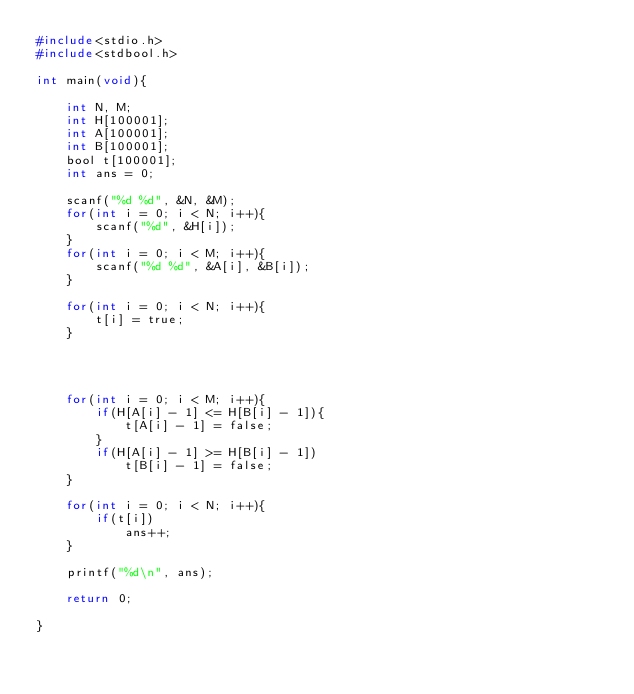Convert code to text. <code><loc_0><loc_0><loc_500><loc_500><_C_>#include<stdio.h>
#include<stdbool.h>

int main(void){

	int N, M;
	int H[100001];
	int A[100001];
	int B[100001];
	bool t[100001];
	int ans = 0;

	scanf("%d %d", &N, &M);
	for(int i = 0; i < N; i++){
		scanf("%d", &H[i]);
	}
	for(int i = 0; i < M; i++){
		scanf("%d %d", &A[i], &B[i]);
	}

	for(int i = 0; i < N; i++){
		t[i] = true;
	}




	for(int i = 0; i < M; i++){
		if(H[A[i] - 1] <= H[B[i] - 1]){
			t[A[i] - 1] = false;
		}
		if(H[A[i] - 1] >= H[B[i] - 1])
			t[B[i] - 1] = false;
	}

	for(int i = 0; i < N; i++){
		if(t[i])
			ans++;
	}

	printf("%d\n", ans);

	return 0;

}
</code> 